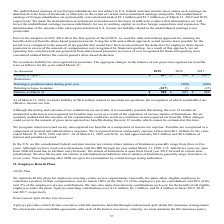According to Agilysys's financial document, What was the liability related to uncertain tax position in 2019? According to the financial document, $0.6 million. The relevant text states: "As of March 31, 2019, we had a liability of $0.6 million related to uncertain tax positions, the recognition of which would affect our effective income tax r..." Also, What was the interest and penalties accrued in 2019? approximately $0.5 million. The document states: "8 and 2017. As of March 31, 2019 and 2018, we had approximately $0.5 million and $0.8 million of interest and penalties accrued...." Also, When did the statute of limitations open? fiscal year 2012 forward in certain state jurisdictions. The document states: "forwards. The statute of limitations is open from fiscal year 2012 forward in certain state jurisdictions. We also file income tax returns in internat..." Also, can you calculate: What was the increase / (decrease) in the Balance at April 1 from 2018 to 2019? Based on the calculation: 687 - 988, the result is -301 (in thousands). This is based on the information: "Balance at April 1 $ 687 $ 988 $ 1,617 Balance at April 1 $ 687 $ 988 $ 1,617..." The key data points involved are: 687, 988. Also, can you calculate: What was the average relating to lapse in statute for 2017-2019? To answer this question, I need to perform calculations using the financial data. The calculation is: -(107 + 1 + 25) / 3, which equals -44.33 (in thousands). This is based on the information: "Relating to lapse in statute (107) (1) (25) Relating to lapse in statute (107) (1) (25) Relating to lapse in statute (107) (1) (25)..." The key data points involved are: 1, 107, 25. Also, can you calculate: What was the percentage increase / (decrease) in the balance at March 31 from 2018 to 2019? To answer this question, I need to perform calculations using the financial data. The calculation is: 580 / 687 - 1, which equals -15.57 (percentage). This is based on the information: "Balance at March 31 $ 580 $ 687 $ 988 Balance at April 1 $ 687 $ 988 $ 1,617..." The key data points involved are: 580, 687. 